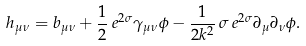Convert formula to latex. <formula><loc_0><loc_0><loc_500><loc_500>h _ { \mu \nu } = b _ { \mu \nu } + \frac { 1 } { 2 } \, e ^ { 2 \sigma } \gamma _ { \mu \nu } \phi - \frac { 1 } { 2 k ^ { 2 } } \, \sigma \, e ^ { 2 \sigma } \partial _ { \mu } \partial _ { \nu } \phi .</formula> 